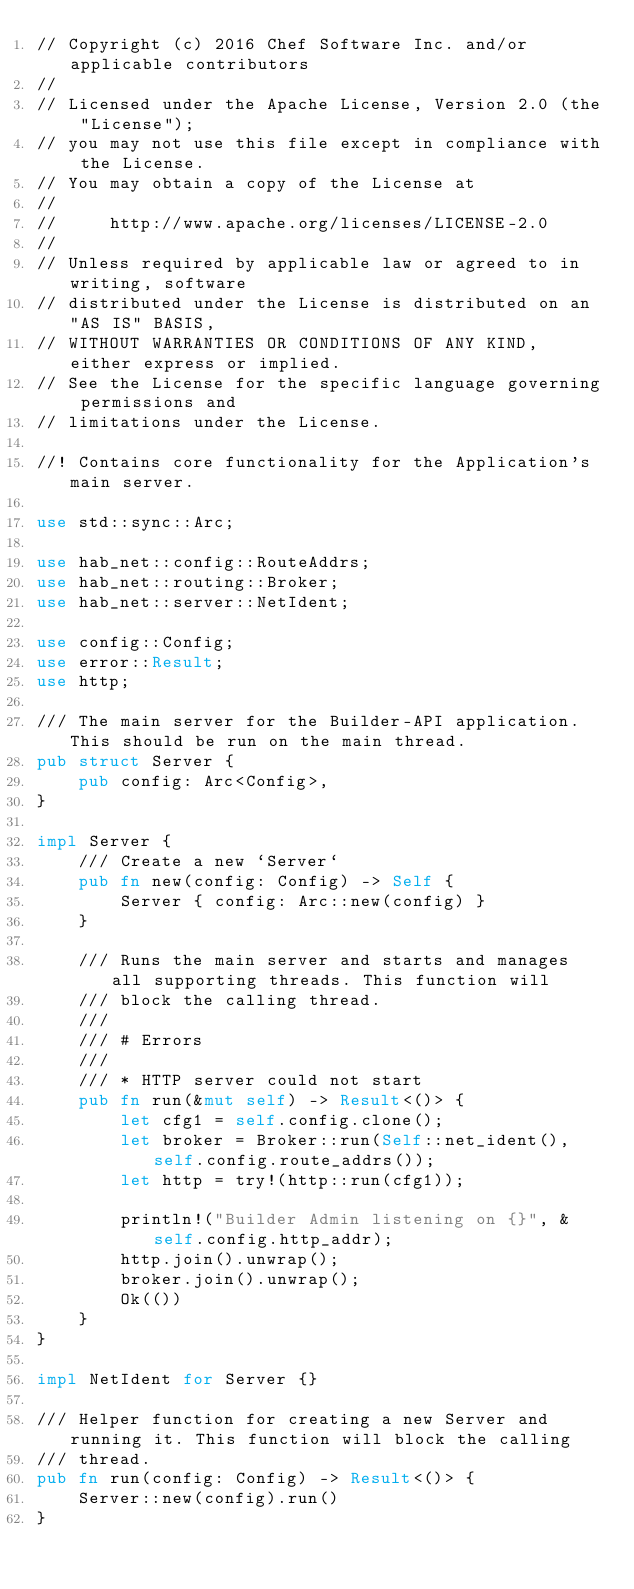Convert code to text. <code><loc_0><loc_0><loc_500><loc_500><_Rust_>// Copyright (c) 2016 Chef Software Inc. and/or applicable contributors
//
// Licensed under the Apache License, Version 2.0 (the "License");
// you may not use this file except in compliance with the License.
// You may obtain a copy of the License at
//
//     http://www.apache.org/licenses/LICENSE-2.0
//
// Unless required by applicable law or agreed to in writing, software
// distributed under the License is distributed on an "AS IS" BASIS,
// WITHOUT WARRANTIES OR CONDITIONS OF ANY KIND, either express or implied.
// See the License for the specific language governing permissions and
// limitations under the License.

//! Contains core functionality for the Application's main server.

use std::sync::Arc;

use hab_net::config::RouteAddrs;
use hab_net::routing::Broker;
use hab_net::server::NetIdent;

use config::Config;
use error::Result;
use http;

/// The main server for the Builder-API application. This should be run on the main thread.
pub struct Server {
    pub config: Arc<Config>,
}

impl Server {
    /// Create a new `Server`
    pub fn new(config: Config) -> Self {
        Server { config: Arc::new(config) }
    }

    /// Runs the main server and starts and manages all supporting threads. This function will
    /// block the calling thread.
    ///
    /// # Errors
    ///
    /// * HTTP server could not start
    pub fn run(&mut self) -> Result<()> {
        let cfg1 = self.config.clone();
        let broker = Broker::run(Self::net_ident(), self.config.route_addrs());
        let http = try!(http::run(cfg1));

        println!("Builder Admin listening on {}", &self.config.http_addr);
        http.join().unwrap();
        broker.join().unwrap();
        Ok(())
    }
}

impl NetIdent for Server {}

/// Helper function for creating a new Server and running it. This function will block the calling
/// thread.
pub fn run(config: Config) -> Result<()> {
    Server::new(config).run()
}
</code> 